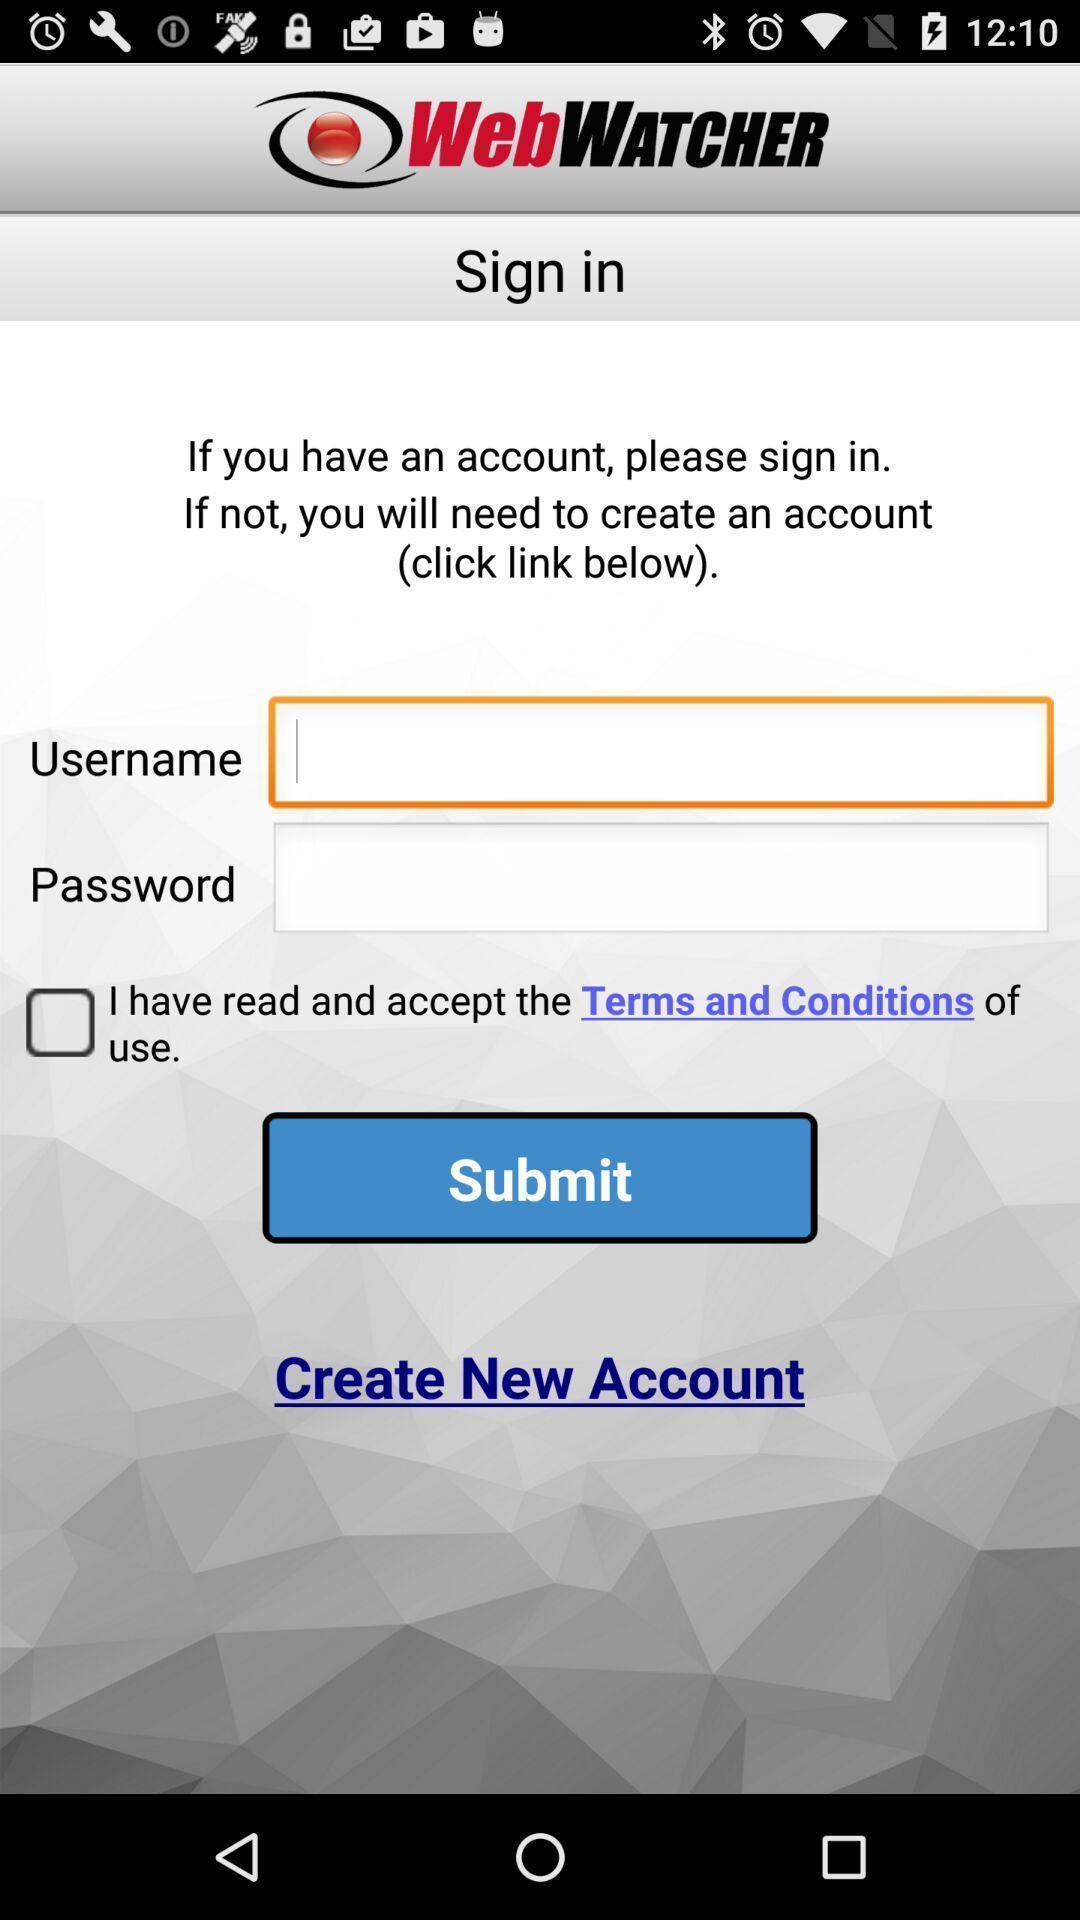Explain what's happening in this screen capture. Welcome page for tracking app. 